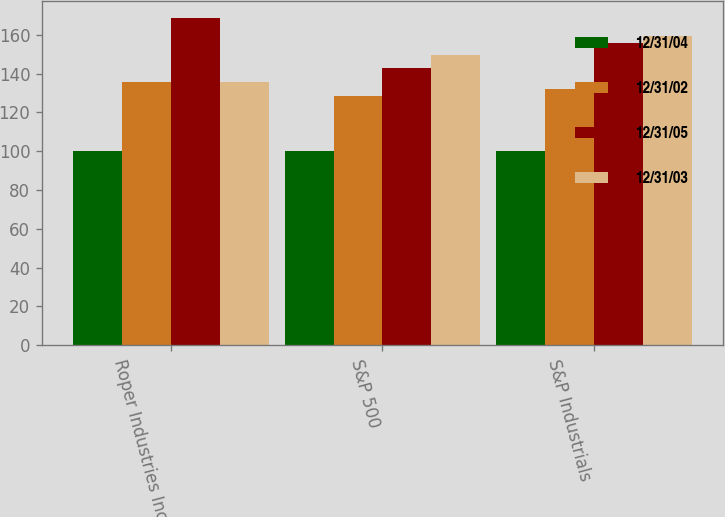Convert chart. <chart><loc_0><loc_0><loc_500><loc_500><stacked_bar_chart><ecel><fcel>Roper Industries Inc<fcel>S&P 500<fcel>S&P Industrials<nl><fcel>12/31/04<fcel>100<fcel>100<fcel>100<nl><fcel>12/31/02<fcel>135.83<fcel>128.68<fcel>132.19<nl><fcel>12/31/05<fcel>168.78<fcel>142.69<fcel>156.03<nl><fcel>12/31/03<fcel>135.83<fcel>149.7<fcel>159.66<nl></chart> 